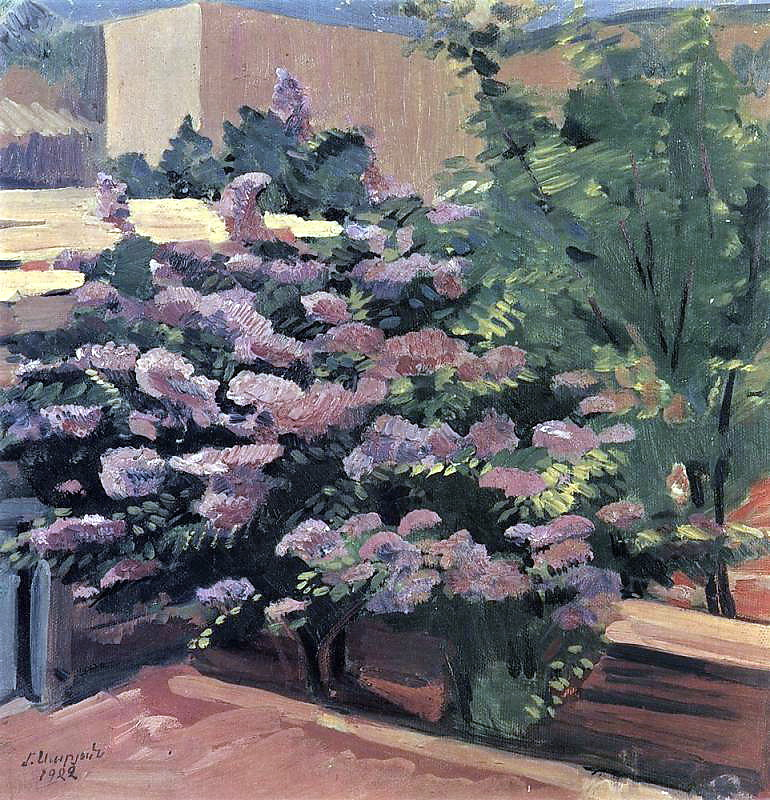What kind of plants aside from the flowering bush might be present in the garden? Aside from the vibrant flowering bush, the garden might contain a variety of other plants such as lush green shrubs, tall leafy trees, and perhaps even some climbing vines. The mix of greenery creates a rich, textured backdrop that complements the central bush, enhancing the overall lushness and tranquility of the scene. 